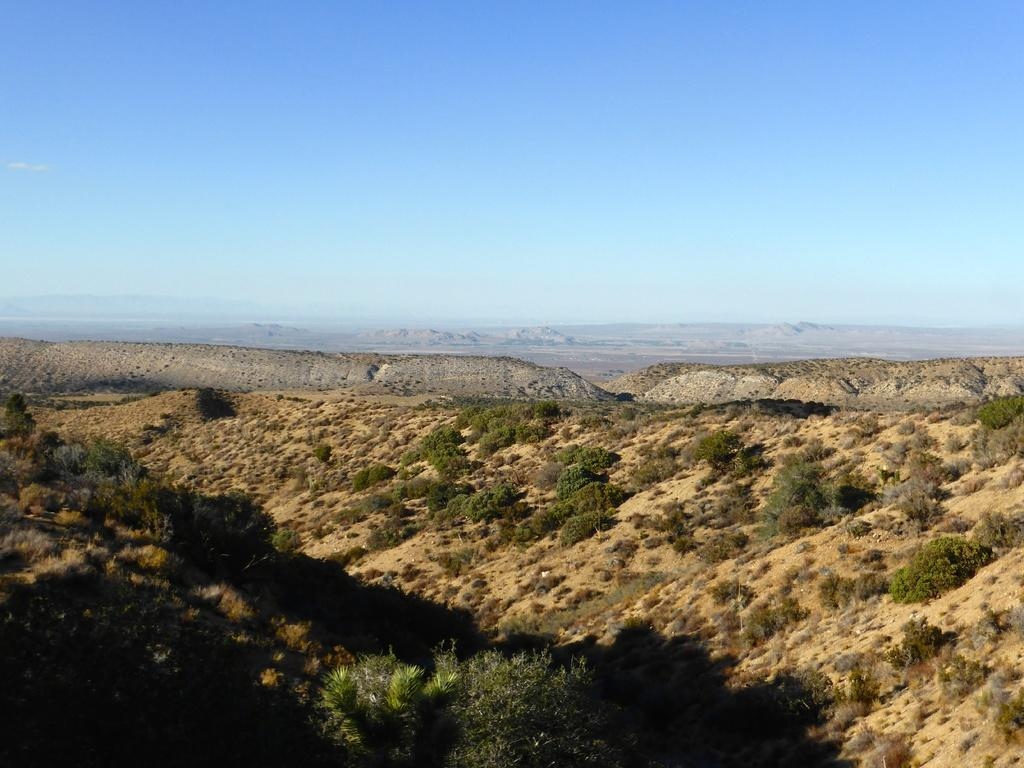What type of natural elements can be seen in the image? There are plants and mountains in the image. What is visible in the background of the image? The sky is visible in the background of the image. What type of mark can be seen on the mountain in the image? There is no mark visible on the mountain in the image. What kind of apparatus is used to maintain the plants in the image? There is no apparatus visible in the image for maintaining the plants. 